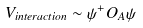Convert formula to latex. <formula><loc_0><loc_0><loc_500><loc_500>V _ { i n t e r a c t i o n } \sim { \psi } ^ { + } O _ { A } \psi</formula> 